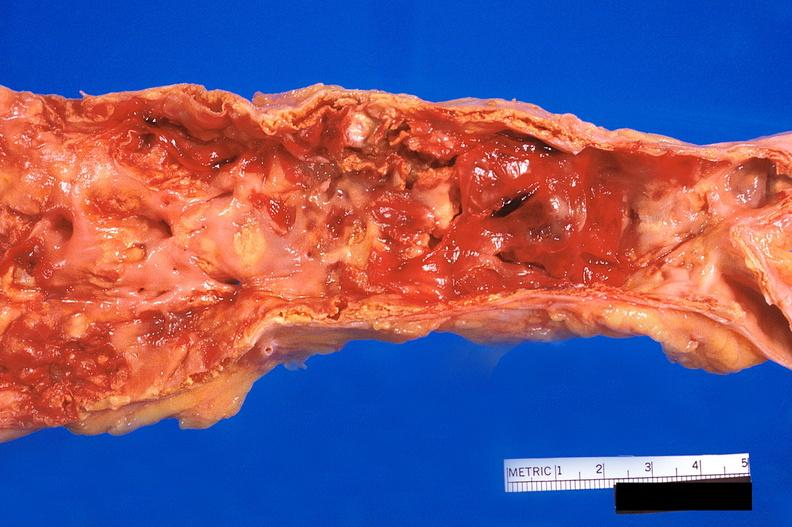does this image show abdominal aorta, atherosclerosis and fusiform aneurysm?
Answer the question using a single word or phrase. Yes 